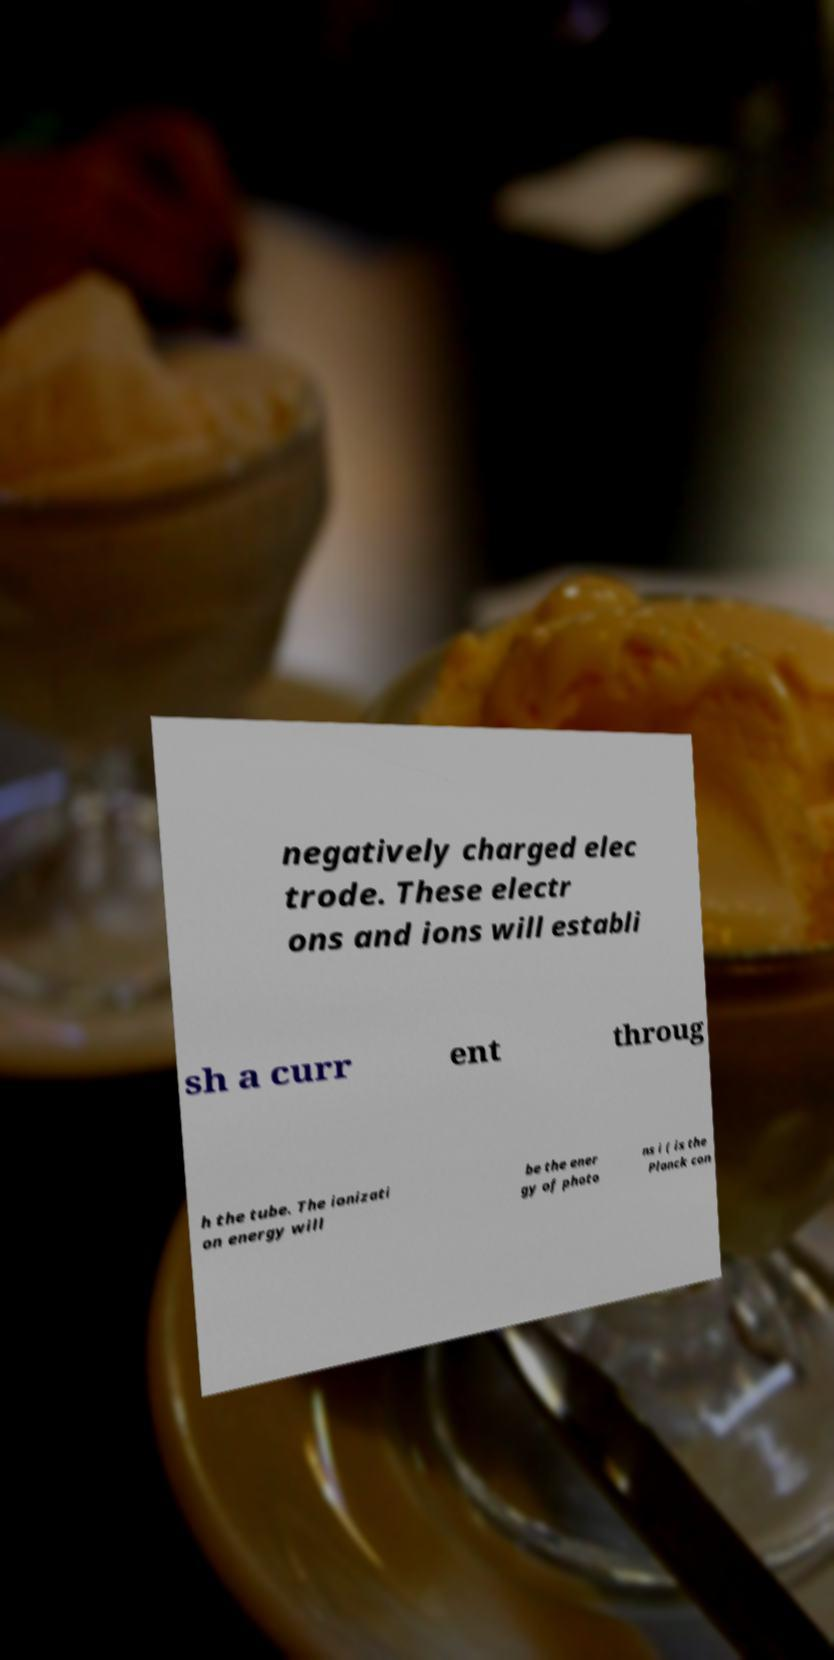There's text embedded in this image that I need extracted. Can you transcribe it verbatim? negatively charged elec trode. These electr ons and ions will establi sh a curr ent throug h the tube. The ionizati on energy will be the ener gy of photo ns i ( is the Planck con 